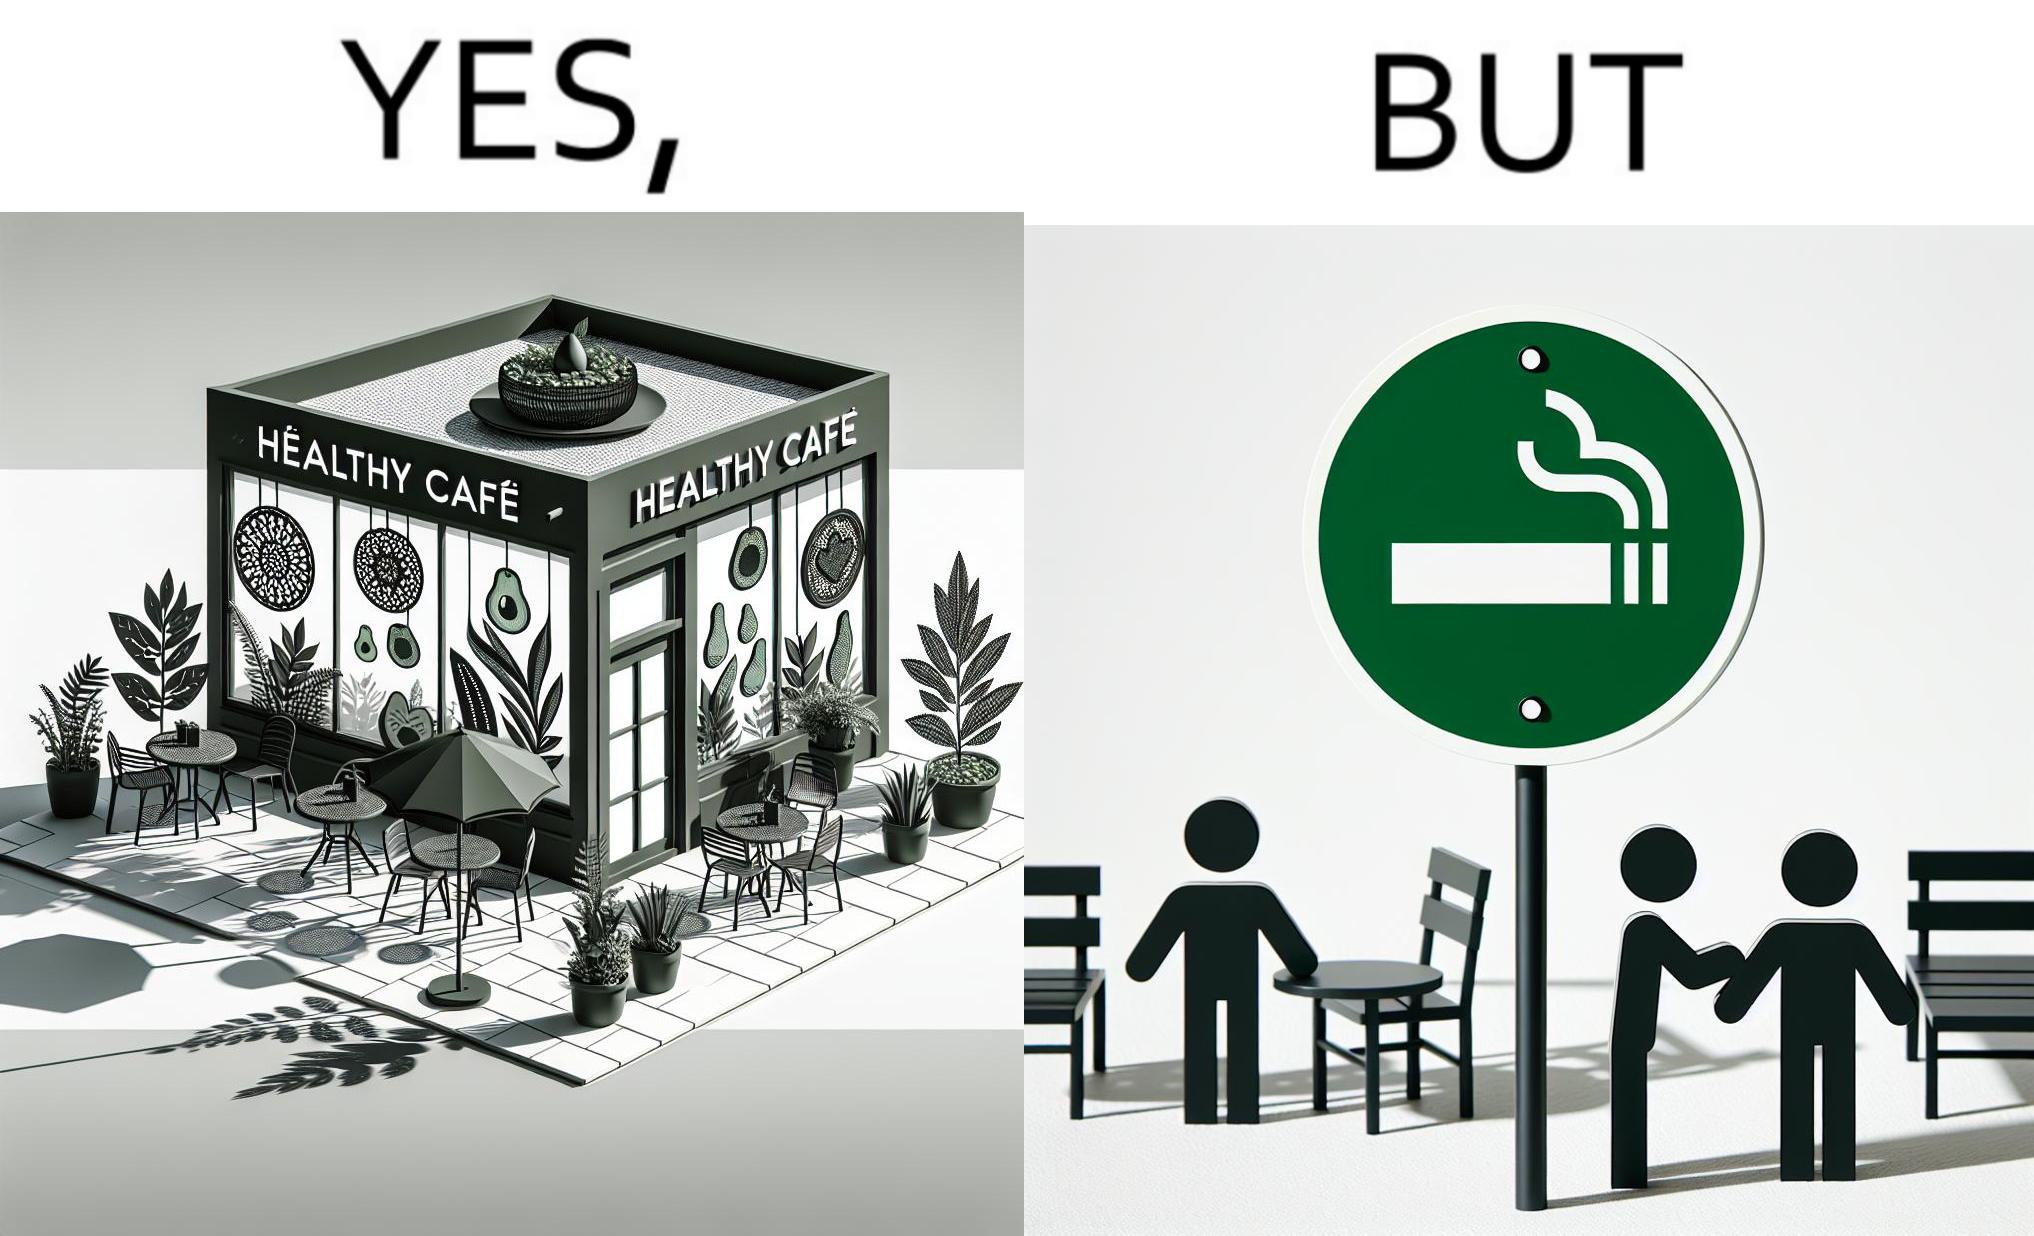Describe the satirical element in this image. This image is funny because an eatery that calls itself the "healthy" cafe also has a smoking area, which is not very "healthy". If it really was a healthy cafe, it would not have a smoking area as smoking is injurious to health. Satire on the behavior of humans - both those that operate this cafe who made the decision of allowing smoking and creating a designated smoking area, and those that visit this healthy cafe to become "healthy", but then also indulge in very unhealthy habits simultaneously. 